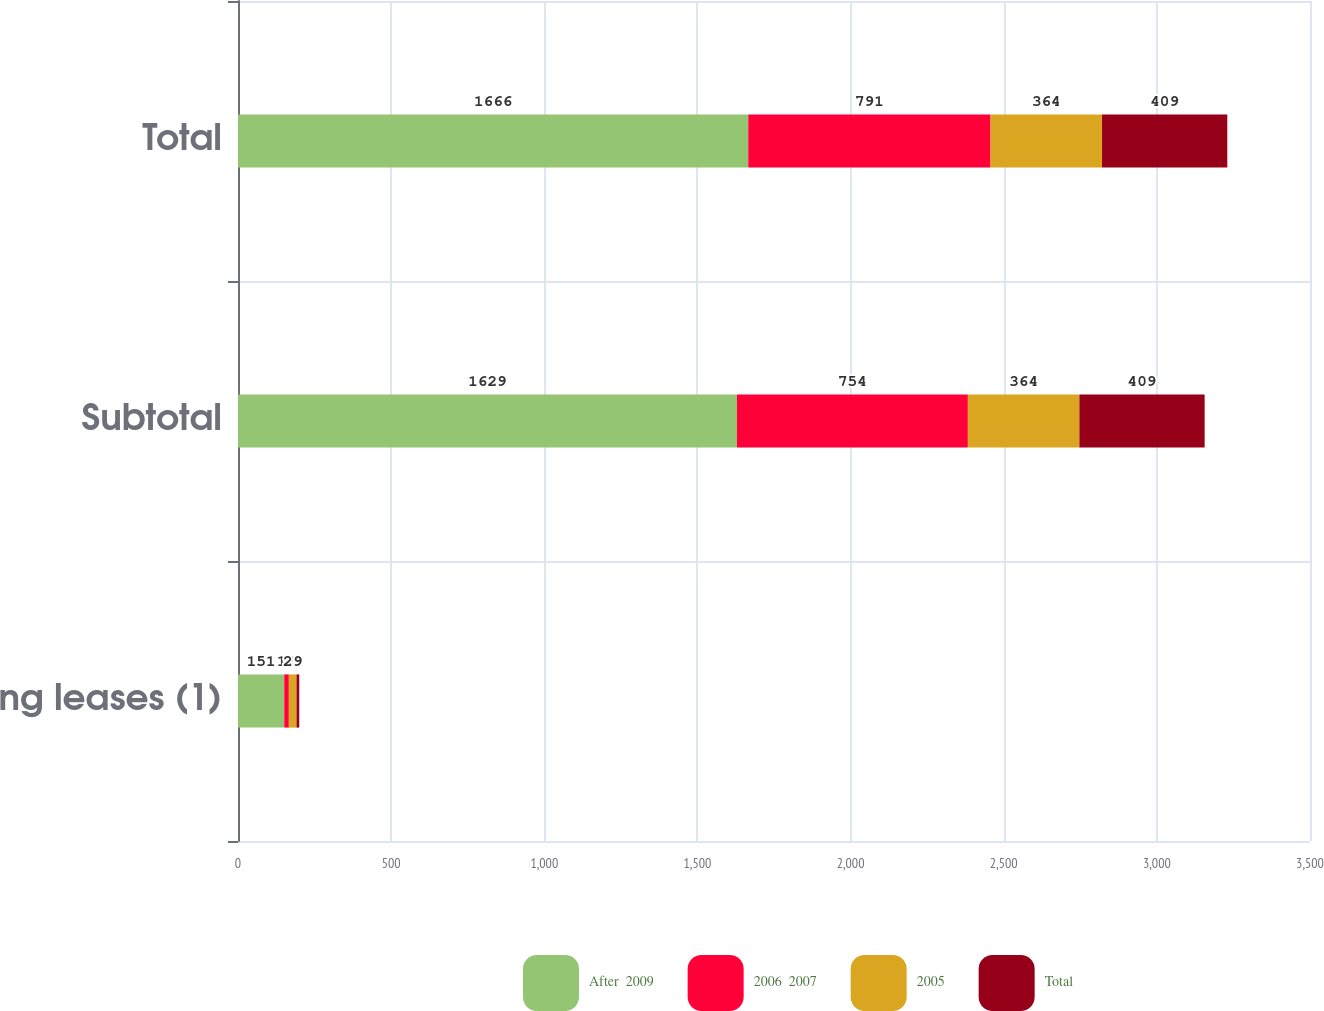<chart> <loc_0><loc_0><loc_500><loc_500><stacked_bar_chart><ecel><fcel>Operating leases (1)<fcel>Subtotal<fcel>Total<nl><fcel>After  2009<fcel>151<fcel>1629<fcel>1666<nl><fcel>2006  2007<fcel>15<fcel>754<fcel>791<nl><fcel>2005<fcel>25<fcel>364<fcel>364<nl><fcel>Total<fcel>9<fcel>409<fcel>409<nl></chart> 